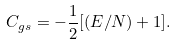<formula> <loc_0><loc_0><loc_500><loc_500>C _ { g s } = - \frac { 1 } { 2 } [ ( E / N ) + 1 ] .</formula> 